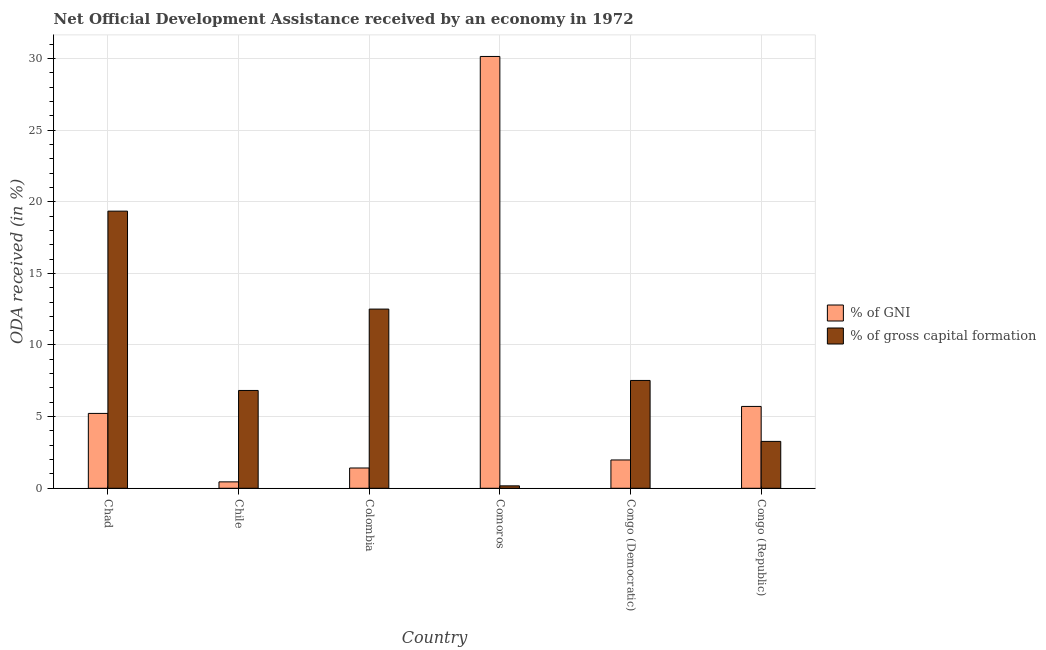Are the number of bars per tick equal to the number of legend labels?
Offer a terse response. Yes. Are the number of bars on each tick of the X-axis equal?
Give a very brief answer. Yes. What is the label of the 3rd group of bars from the left?
Ensure brevity in your answer.  Colombia. What is the oda received as percentage of gni in Colombia?
Keep it short and to the point. 1.42. Across all countries, what is the maximum oda received as percentage of gni?
Offer a terse response. 30.14. Across all countries, what is the minimum oda received as percentage of gni?
Offer a very short reply. 0.45. In which country was the oda received as percentage of gross capital formation maximum?
Offer a terse response. Chad. In which country was the oda received as percentage of gni minimum?
Give a very brief answer. Chile. What is the total oda received as percentage of gross capital formation in the graph?
Make the answer very short. 49.64. What is the difference between the oda received as percentage of gni in Chile and that in Congo (Republic)?
Keep it short and to the point. -5.27. What is the difference between the oda received as percentage of gross capital formation in Chile and the oda received as percentage of gni in Colombia?
Provide a short and direct response. 5.41. What is the average oda received as percentage of gross capital formation per country?
Your answer should be very brief. 8.27. What is the difference between the oda received as percentage of gni and oda received as percentage of gross capital formation in Colombia?
Your answer should be compact. -11.09. What is the ratio of the oda received as percentage of gni in Chad to that in Chile?
Your answer should be compact. 11.69. What is the difference between the highest and the second highest oda received as percentage of gni?
Give a very brief answer. 24.42. What is the difference between the highest and the lowest oda received as percentage of gni?
Give a very brief answer. 29.69. What does the 2nd bar from the left in Comoros represents?
Offer a terse response. % of gross capital formation. What does the 2nd bar from the right in Chile represents?
Provide a succinct answer. % of GNI. How many countries are there in the graph?
Your response must be concise. 6. What is the difference between two consecutive major ticks on the Y-axis?
Make the answer very short. 5. Are the values on the major ticks of Y-axis written in scientific E-notation?
Provide a short and direct response. No. Does the graph contain any zero values?
Give a very brief answer. No. Where does the legend appear in the graph?
Offer a terse response. Center right. What is the title of the graph?
Offer a very short reply. Net Official Development Assistance received by an economy in 1972. Does "Largest city" appear as one of the legend labels in the graph?
Your answer should be very brief. No. What is the label or title of the Y-axis?
Your answer should be compact. ODA received (in %). What is the ODA received (in %) of % of GNI in Chad?
Your answer should be very brief. 5.23. What is the ODA received (in %) in % of gross capital formation in Chad?
Your response must be concise. 19.34. What is the ODA received (in %) in % of GNI in Chile?
Give a very brief answer. 0.45. What is the ODA received (in %) of % of gross capital formation in Chile?
Keep it short and to the point. 6.83. What is the ODA received (in %) in % of GNI in Colombia?
Provide a short and direct response. 1.42. What is the ODA received (in %) in % of gross capital formation in Colombia?
Ensure brevity in your answer.  12.51. What is the ODA received (in %) of % of GNI in Comoros?
Your answer should be very brief. 30.14. What is the ODA received (in %) in % of gross capital formation in Comoros?
Provide a short and direct response. 0.17. What is the ODA received (in %) in % of GNI in Congo (Democratic)?
Offer a terse response. 1.98. What is the ODA received (in %) of % of gross capital formation in Congo (Democratic)?
Give a very brief answer. 7.53. What is the ODA received (in %) of % of GNI in Congo (Republic)?
Make the answer very short. 5.71. What is the ODA received (in %) of % of gross capital formation in Congo (Republic)?
Your answer should be compact. 3.27. Across all countries, what is the maximum ODA received (in %) of % of GNI?
Offer a terse response. 30.14. Across all countries, what is the maximum ODA received (in %) in % of gross capital formation?
Offer a very short reply. 19.34. Across all countries, what is the minimum ODA received (in %) of % of GNI?
Your answer should be compact. 0.45. Across all countries, what is the minimum ODA received (in %) of % of gross capital formation?
Provide a succinct answer. 0.17. What is the total ODA received (in %) in % of GNI in the graph?
Offer a very short reply. 44.91. What is the total ODA received (in %) in % of gross capital formation in the graph?
Offer a terse response. 49.64. What is the difference between the ODA received (in %) of % of GNI in Chad and that in Chile?
Provide a succinct answer. 4.78. What is the difference between the ODA received (in %) in % of gross capital formation in Chad and that in Chile?
Give a very brief answer. 12.51. What is the difference between the ODA received (in %) in % of GNI in Chad and that in Colombia?
Give a very brief answer. 3.81. What is the difference between the ODA received (in %) in % of gross capital formation in Chad and that in Colombia?
Give a very brief answer. 6.84. What is the difference between the ODA received (in %) of % of GNI in Chad and that in Comoros?
Your answer should be compact. -24.91. What is the difference between the ODA received (in %) of % of gross capital formation in Chad and that in Comoros?
Your response must be concise. 19.17. What is the difference between the ODA received (in %) in % of GNI in Chad and that in Congo (Democratic)?
Your answer should be compact. 3.25. What is the difference between the ODA received (in %) of % of gross capital formation in Chad and that in Congo (Democratic)?
Your response must be concise. 11.82. What is the difference between the ODA received (in %) of % of GNI in Chad and that in Congo (Republic)?
Your answer should be compact. -0.49. What is the difference between the ODA received (in %) of % of gross capital formation in Chad and that in Congo (Republic)?
Provide a short and direct response. 16.07. What is the difference between the ODA received (in %) of % of GNI in Chile and that in Colombia?
Ensure brevity in your answer.  -0.97. What is the difference between the ODA received (in %) in % of gross capital formation in Chile and that in Colombia?
Offer a very short reply. -5.68. What is the difference between the ODA received (in %) of % of GNI in Chile and that in Comoros?
Make the answer very short. -29.69. What is the difference between the ODA received (in %) in % of gross capital formation in Chile and that in Comoros?
Offer a very short reply. 6.66. What is the difference between the ODA received (in %) of % of GNI in Chile and that in Congo (Democratic)?
Offer a very short reply. -1.53. What is the difference between the ODA received (in %) in % of gross capital formation in Chile and that in Congo (Democratic)?
Keep it short and to the point. -0.7. What is the difference between the ODA received (in %) of % of GNI in Chile and that in Congo (Republic)?
Offer a terse response. -5.27. What is the difference between the ODA received (in %) in % of gross capital formation in Chile and that in Congo (Republic)?
Keep it short and to the point. 3.55. What is the difference between the ODA received (in %) in % of GNI in Colombia and that in Comoros?
Offer a terse response. -28.72. What is the difference between the ODA received (in %) of % of gross capital formation in Colombia and that in Comoros?
Your response must be concise. 12.34. What is the difference between the ODA received (in %) in % of GNI in Colombia and that in Congo (Democratic)?
Offer a very short reply. -0.56. What is the difference between the ODA received (in %) in % of gross capital formation in Colombia and that in Congo (Democratic)?
Offer a very short reply. 4.98. What is the difference between the ODA received (in %) of % of GNI in Colombia and that in Congo (Republic)?
Offer a very short reply. -4.3. What is the difference between the ODA received (in %) of % of gross capital formation in Colombia and that in Congo (Republic)?
Keep it short and to the point. 9.23. What is the difference between the ODA received (in %) in % of GNI in Comoros and that in Congo (Democratic)?
Provide a short and direct response. 28.16. What is the difference between the ODA received (in %) of % of gross capital formation in Comoros and that in Congo (Democratic)?
Ensure brevity in your answer.  -7.36. What is the difference between the ODA received (in %) of % of GNI in Comoros and that in Congo (Republic)?
Your answer should be compact. 24.42. What is the difference between the ODA received (in %) of % of gross capital formation in Comoros and that in Congo (Republic)?
Ensure brevity in your answer.  -3.1. What is the difference between the ODA received (in %) of % of GNI in Congo (Democratic) and that in Congo (Republic)?
Offer a very short reply. -3.74. What is the difference between the ODA received (in %) of % of gross capital formation in Congo (Democratic) and that in Congo (Republic)?
Offer a very short reply. 4.25. What is the difference between the ODA received (in %) of % of GNI in Chad and the ODA received (in %) of % of gross capital formation in Chile?
Offer a very short reply. -1.6. What is the difference between the ODA received (in %) of % of GNI in Chad and the ODA received (in %) of % of gross capital formation in Colombia?
Ensure brevity in your answer.  -7.28. What is the difference between the ODA received (in %) in % of GNI in Chad and the ODA received (in %) in % of gross capital formation in Comoros?
Your answer should be very brief. 5.06. What is the difference between the ODA received (in %) of % of GNI in Chad and the ODA received (in %) of % of gross capital formation in Congo (Democratic)?
Provide a succinct answer. -2.3. What is the difference between the ODA received (in %) of % of GNI in Chad and the ODA received (in %) of % of gross capital formation in Congo (Republic)?
Your response must be concise. 1.95. What is the difference between the ODA received (in %) in % of GNI in Chile and the ODA received (in %) in % of gross capital formation in Colombia?
Your answer should be very brief. -12.06. What is the difference between the ODA received (in %) in % of GNI in Chile and the ODA received (in %) in % of gross capital formation in Comoros?
Your answer should be compact. 0.28. What is the difference between the ODA received (in %) of % of GNI in Chile and the ODA received (in %) of % of gross capital formation in Congo (Democratic)?
Provide a succinct answer. -7.08. What is the difference between the ODA received (in %) in % of GNI in Chile and the ODA received (in %) in % of gross capital formation in Congo (Republic)?
Your answer should be very brief. -2.82. What is the difference between the ODA received (in %) in % of GNI in Colombia and the ODA received (in %) in % of gross capital formation in Comoros?
Keep it short and to the point. 1.25. What is the difference between the ODA received (in %) of % of GNI in Colombia and the ODA received (in %) of % of gross capital formation in Congo (Democratic)?
Provide a short and direct response. -6.11. What is the difference between the ODA received (in %) in % of GNI in Colombia and the ODA received (in %) in % of gross capital formation in Congo (Republic)?
Ensure brevity in your answer.  -1.86. What is the difference between the ODA received (in %) of % of GNI in Comoros and the ODA received (in %) of % of gross capital formation in Congo (Democratic)?
Your response must be concise. 22.61. What is the difference between the ODA received (in %) of % of GNI in Comoros and the ODA received (in %) of % of gross capital formation in Congo (Republic)?
Your answer should be compact. 26.86. What is the difference between the ODA received (in %) in % of GNI in Congo (Democratic) and the ODA received (in %) in % of gross capital formation in Congo (Republic)?
Your answer should be very brief. -1.3. What is the average ODA received (in %) of % of GNI per country?
Provide a succinct answer. 7.49. What is the average ODA received (in %) of % of gross capital formation per country?
Your answer should be very brief. 8.27. What is the difference between the ODA received (in %) in % of GNI and ODA received (in %) in % of gross capital formation in Chad?
Give a very brief answer. -14.12. What is the difference between the ODA received (in %) of % of GNI and ODA received (in %) of % of gross capital formation in Chile?
Make the answer very short. -6.38. What is the difference between the ODA received (in %) in % of GNI and ODA received (in %) in % of gross capital formation in Colombia?
Make the answer very short. -11.09. What is the difference between the ODA received (in %) of % of GNI and ODA received (in %) of % of gross capital formation in Comoros?
Make the answer very short. 29.97. What is the difference between the ODA received (in %) of % of GNI and ODA received (in %) of % of gross capital formation in Congo (Democratic)?
Your answer should be compact. -5.55. What is the difference between the ODA received (in %) of % of GNI and ODA received (in %) of % of gross capital formation in Congo (Republic)?
Provide a short and direct response. 2.44. What is the ratio of the ODA received (in %) of % of GNI in Chad to that in Chile?
Your answer should be compact. 11.69. What is the ratio of the ODA received (in %) of % of gross capital formation in Chad to that in Chile?
Offer a terse response. 2.83. What is the ratio of the ODA received (in %) in % of GNI in Chad to that in Colombia?
Give a very brief answer. 3.69. What is the ratio of the ODA received (in %) of % of gross capital formation in Chad to that in Colombia?
Ensure brevity in your answer.  1.55. What is the ratio of the ODA received (in %) in % of GNI in Chad to that in Comoros?
Offer a very short reply. 0.17. What is the ratio of the ODA received (in %) in % of gross capital formation in Chad to that in Comoros?
Offer a very short reply. 114.31. What is the ratio of the ODA received (in %) of % of GNI in Chad to that in Congo (Democratic)?
Keep it short and to the point. 2.64. What is the ratio of the ODA received (in %) of % of gross capital formation in Chad to that in Congo (Democratic)?
Offer a very short reply. 2.57. What is the ratio of the ODA received (in %) in % of GNI in Chad to that in Congo (Republic)?
Your response must be concise. 0.91. What is the ratio of the ODA received (in %) in % of gross capital formation in Chad to that in Congo (Republic)?
Give a very brief answer. 5.91. What is the ratio of the ODA received (in %) in % of GNI in Chile to that in Colombia?
Give a very brief answer. 0.32. What is the ratio of the ODA received (in %) in % of gross capital formation in Chile to that in Colombia?
Make the answer very short. 0.55. What is the ratio of the ODA received (in %) of % of GNI in Chile to that in Comoros?
Make the answer very short. 0.01. What is the ratio of the ODA received (in %) in % of gross capital formation in Chile to that in Comoros?
Your response must be concise. 40.34. What is the ratio of the ODA received (in %) in % of GNI in Chile to that in Congo (Democratic)?
Give a very brief answer. 0.23. What is the ratio of the ODA received (in %) in % of gross capital formation in Chile to that in Congo (Democratic)?
Your answer should be compact. 0.91. What is the ratio of the ODA received (in %) in % of GNI in Chile to that in Congo (Republic)?
Offer a very short reply. 0.08. What is the ratio of the ODA received (in %) in % of gross capital formation in Chile to that in Congo (Republic)?
Your response must be concise. 2.09. What is the ratio of the ODA received (in %) of % of GNI in Colombia to that in Comoros?
Provide a succinct answer. 0.05. What is the ratio of the ODA received (in %) of % of gross capital formation in Colombia to that in Comoros?
Provide a short and direct response. 73.91. What is the ratio of the ODA received (in %) of % of GNI in Colombia to that in Congo (Democratic)?
Provide a succinct answer. 0.72. What is the ratio of the ODA received (in %) in % of gross capital formation in Colombia to that in Congo (Democratic)?
Your answer should be compact. 1.66. What is the ratio of the ODA received (in %) in % of GNI in Colombia to that in Congo (Republic)?
Your response must be concise. 0.25. What is the ratio of the ODA received (in %) of % of gross capital formation in Colombia to that in Congo (Republic)?
Your response must be concise. 3.82. What is the ratio of the ODA received (in %) of % of GNI in Comoros to that in Congo (Democratic)?
Make the answer very short. 15.25. What is the ratio of the ODA received (in %) of % of gross capital formation in Comoros to that in Congo (Democratic)?
Your response must be concise. 0.02. What is the ratio of the ODA received (in %) of % of GNI in Comoros to that in Congo (Republic)?
Offer a terse response. 5.28. What is the ratio of the ODA received (in %) in % of gross capital formation in Comoros to that in Congo (Republic)?
Provide a short and direct response. 0.05. What is the ratio of the ODA received (in %) of % of GNI in Congo (Democratic) to that in Congo (Republic)?
Your response must be concise. 0.35. What is the ratio of the ODA received (in %) in % of gross capital formation in Congo (Democratic) to that in Congo (Republic)?
Your answer should be very brief. 2.3. What is the difference between the highest and the second highest ODA received (in %) in % of GNI?
Your answer should be very brief. 24.42. What is the difference between the highest and the second highest ODA received (in %) of % of gross capital formation?
Your answer should be compact. 6.84. What is the difference between the highest and the lowest ODA received (in %) of % of GNI?
Ensure brevity in your answer.  29.69. What is the difference between the highest and the lowest ODA received (in %) in % of gross capital formation?
Offer a terse response. 19.17. 